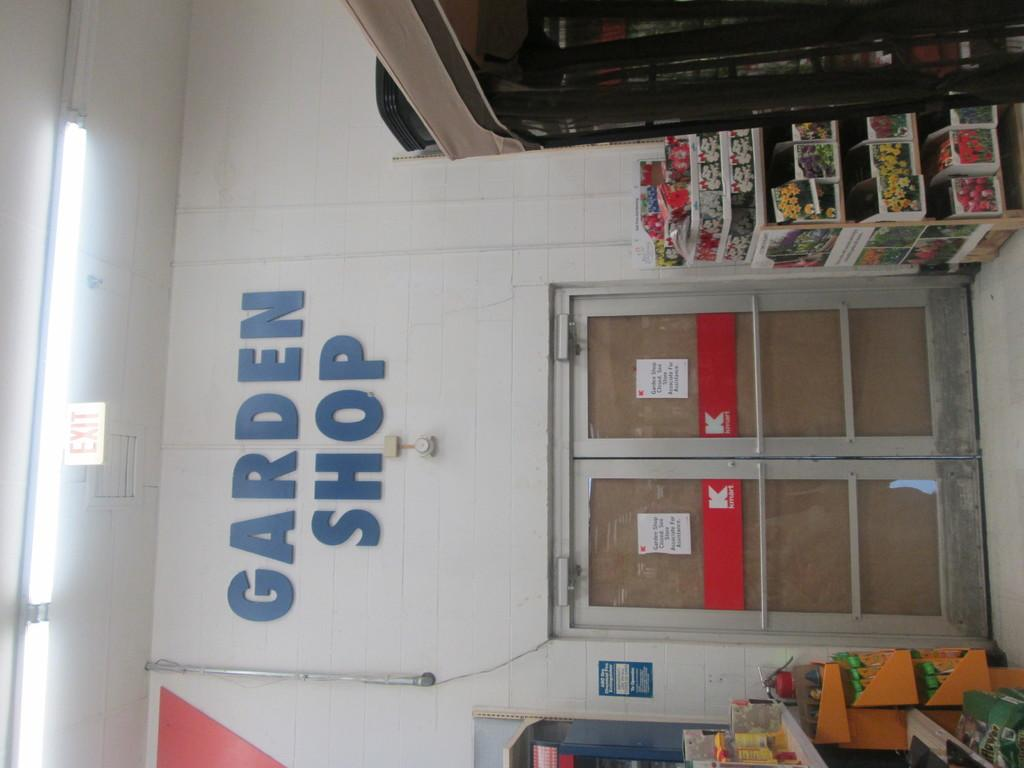<image>
Render a clear and concise summary of the photo. The sign inside the building is for the garden shop 